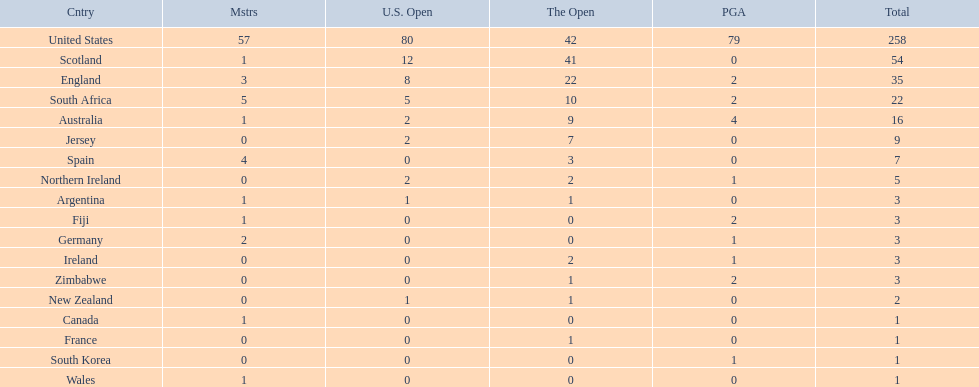What countries in the championship were from africa? South Africa, Zimbabwe. Which of these counteries had the least championship golfers Zimbabwe. 